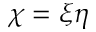<formula> <loc_0><loc_0><loc_500><loc_500>\chi = \xi \eta</formula> 